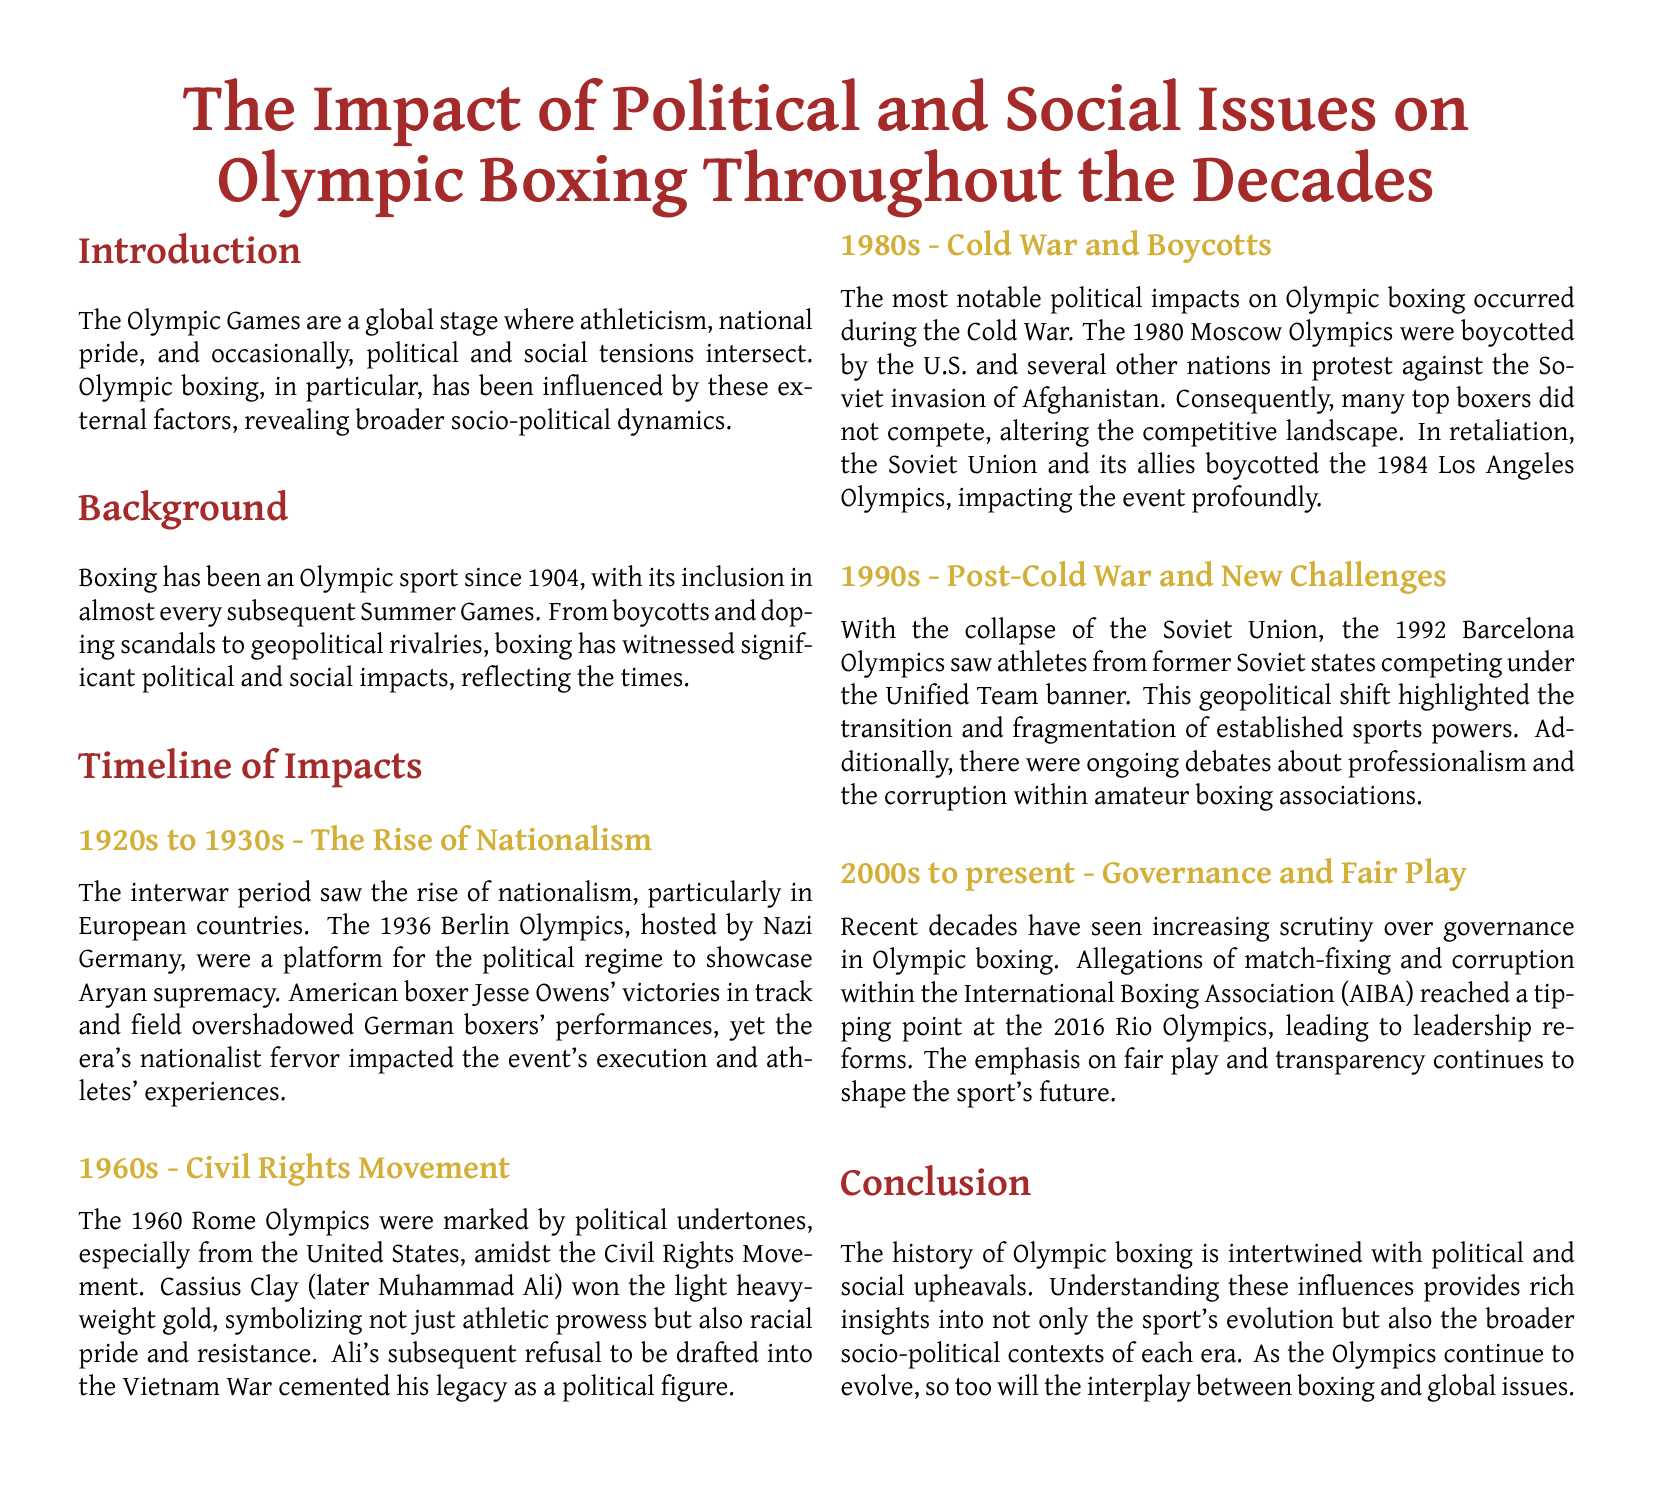What significant event occurred during the 1936 Berlin Olympics? The 1936 Berlin Olympics were a platform for the political regime to showcase Aryan supremacy.
Answer: Aryan supremacy Who won the light heavyweight gold medal in the 1960 Rome Olympics? Cassius Clay (later Muhammad Ali) won the light heavyweight gold medal.
Answer: Cassius Clay What political event prompted the U.S. boycott of the 1980 Moscow Olympics? The U.S. and several other nations boycotted in protest against the Soviet invasion of Afghanistan.
Answer: Soviet invasion of Afghanistan Which two Olympics were impacted by boycotts during the Cold War? The boycotts occurred during the 1980 Moscow Olympics and the 1984 Los Angeles Olympics.
Answer: 1980 Moscow Olympics and 1984 Los Angeles Olympics In what year did the Unified Team compete in the Olympics? The Unified Team competed in the 1992 Barcelona Olympics.
Answer: 1992 Barcelona Olympics What major issue emerged in Olympic boxing during the 2016 Rio Olympics? Allegations of match-fixing and corruption within the International Boxing Association (AIBA) arose.
Answer: Match-fixing and corruption What overarching theme is discussed in the conclusion of the document? The history of Olympic boxing is intertwined with political and social upheavals.
Answer: Political and social upheavals During which decade did the Civil Rights Movement influence Olympic boxing? The document mentions the influence during the 1960s.
Answer: 1960s What has been emphasized in recent decades regarding Olympic boxing governance? The emphasis has been on fair play and transparency.
Answer: Fair play and transparency 